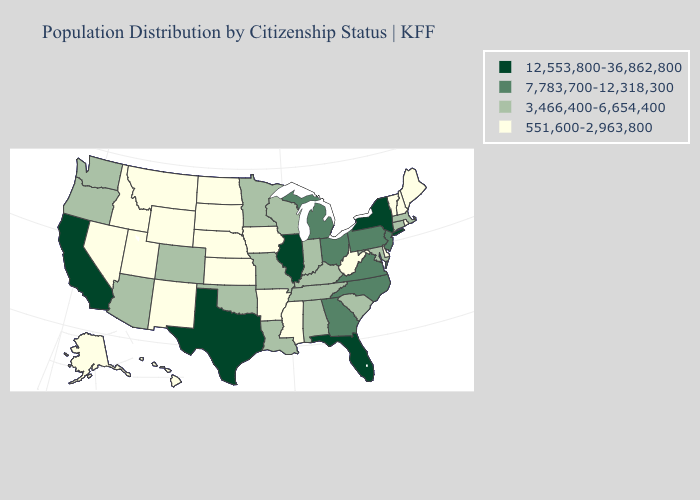Name the states that have a value in the range 3,466,400-6,654,400?
Answer briefly. Alabama, Arizona, Colorado, Connecticut, Indiana, Kentucky, Louisiana, Maryland, Massachusetts, Minnesota, Missouri, Oklahoma, Oregon, South Carolina, Tennessee, Washington, Wisconsin. Which states hav the highest value in the South?
Be succinct. Florida, Texas. Name the states that have a value in the range 7,783,700-12,318,300?
Give a very brief answer. Georgia, Michigan, New Jersey, North Carolina, Ohio, Pennsylvania, Virginia. What is the value of Nevada?
Quick response, please. 551,600-2,963,800. Name the states that have a value in the range 12,553,800-36,862,800?
Give a very brief answer. California, Florida, Illinois, New York, Texas. Is the legend a continuous bar?
Answer briefly. No. What is the value of New Mexico?
Quick response, please. 551,600-2,963,800. Which states have the lowest value in the West?
Concise answer only. Alaska, Hawaii, Idaho, Montana, Nevada, New Mexico, Utah, Wyoming. Name the states that have a value in the range 12,553,800-36,862,800?
Quick response, please. California, Florida, Illinois, New York, Texas. Name the states that have a value in the range 7,783,700-12,318,300?
Be succinct. Georgia, Michigan, New Jersey, North Carolina, Ohio, Pennsylvania, Virginia. Does Texas have the highest value in the USA?
Keep it brief. Yes. What is the value of Vermont?
Answer briefly. 551,600-2,963,800. What is the value of Delaware?
Concise answer only. 551,600-2,963,800. What is the highest value in the West ?
Answer briefly. 12,553,800-36,862,800. What is the value of Mississippi?
Give a very brief answer. 551,600-2,963,800. 